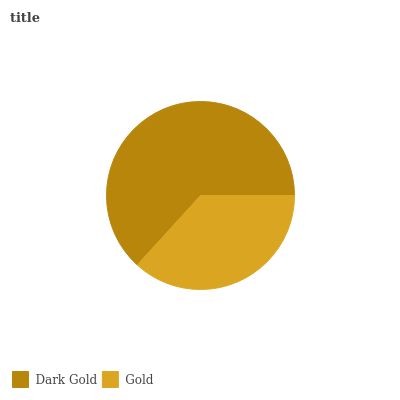Is Gold the minimum?
Answer yes or no. Yes. Is Dark Gold the maximum?
Answer yes or no. Yes. Is Gold the maximum?
Answer yes or no. No. Is Dark Gold greater than Gold?
Answer yes or no. Yes. Is Gold less than Dark Gold?
Answer yes or no. Yes. Is Gold greater than Dark Gold?
Answer yes or no. No. Is Dark Gold less than Gold?
Answer yes or no. No. Is Dark Gold the high median?
Answer yes or no. Yes. Is Gold the low median?
Answer yes or no. Yes. Is Gold the high median?
Answer yes or no. No. Is Dark Gold the low median?
Answer yes or no. No. 